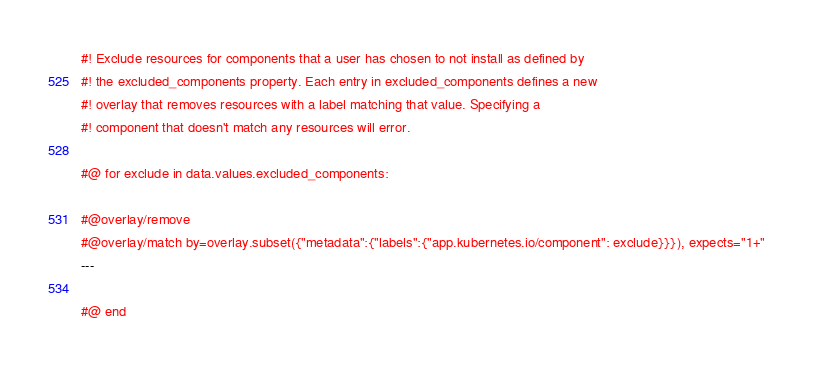Convert code to text. <code><loc_0><loc_0><loc_500><loc_500><_YAML_>#! Exclude resources for components that a user has chosen to not install as defined by
#! the excluded_components property. Each entry in excluded_components defines a new
#! overlay that removes resources with a label matching that value. Specifying a
#! component that doesn't match any resources will error.

#@ for exclude in data.values.excluded_components:

#@overlay/remove
#@overlay/match by=overlay.subset({"metadata":{"labels":{"app.kubernetes.io/component": exclude}}}), expects="1+"
---

#@ end
</code> 